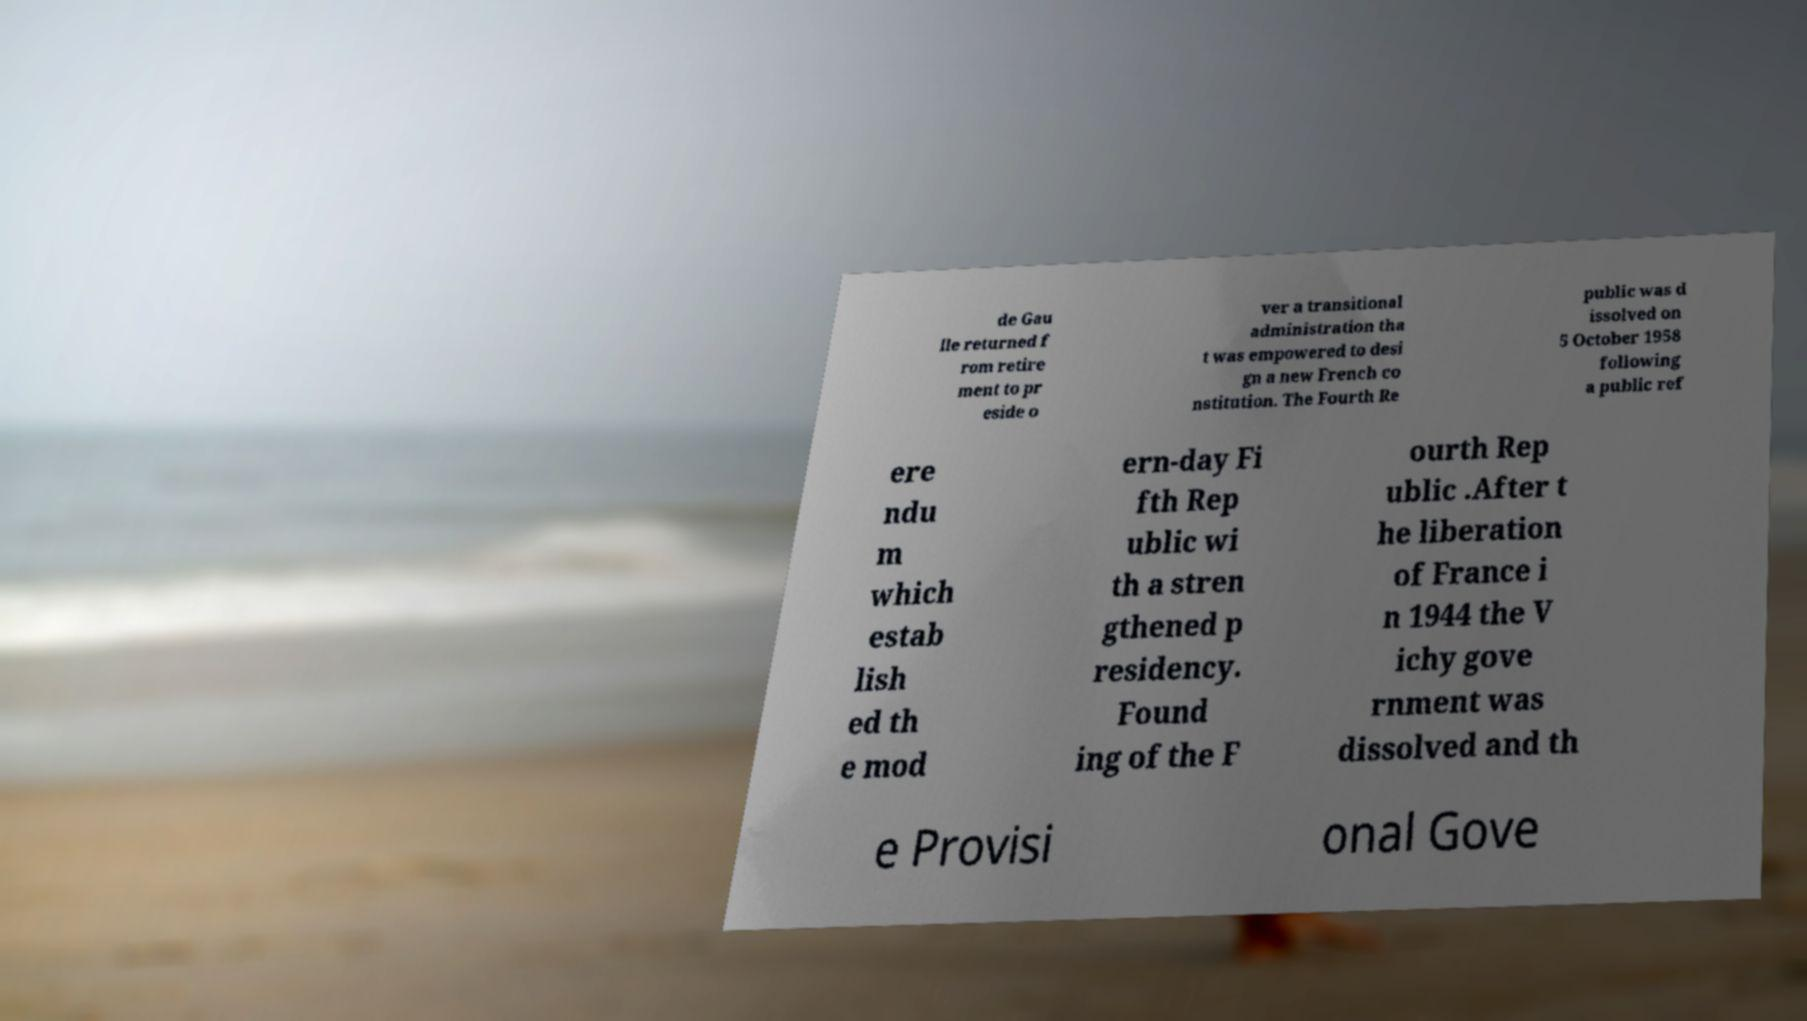I need the written content from this picture converted into text. Can you do that? de Gau lle returned f rom retire ment to pr eside o ver a transitional administration tha t was empowered to desi gn a new French co nstitution. The Fourth Re public was d issolved on 5 October 1958 following a public ref ere ndu m which estab lish ed th e mod ern-day Fi fth Rep ublic wi th a stren gthened p residency. Found ing of the F ourth Rep ublic .After t he liberation of France i n 1944 the V ichy gove rnment was dissolved and th e Provisi onal Gove 